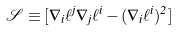<formula> <loc_0><loc_0><loc_500><loc_500>\mathcal { S } \equiv [ \nabla _ { i } \ell ^ { j } \nabla _ { j } \ell ^ { i } - ( \nabla _ { i } \ell ^ { i } ) ^ { 2 } ]</formula> 